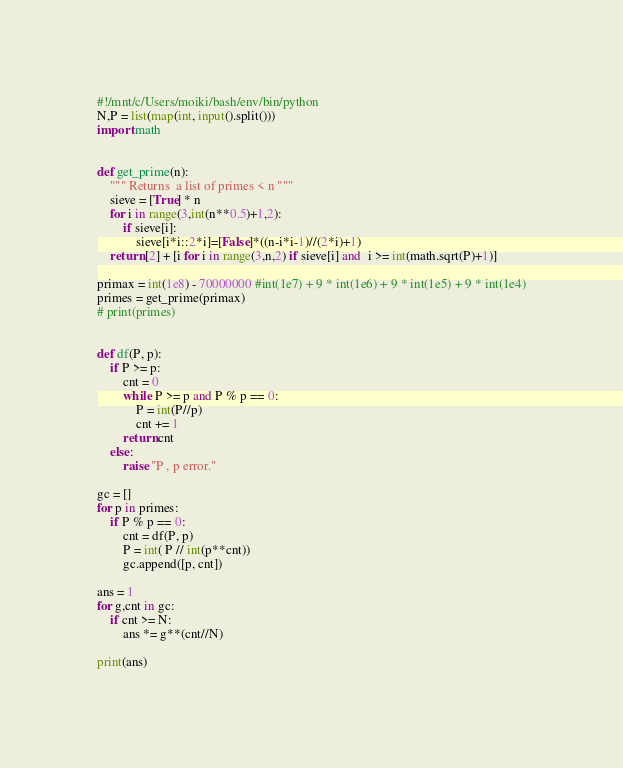Convert code to text. <code><loc_0><loc_0><loc_500><loc_500><_Python_>#!/mnt/c/Users/moiki/bash/env/bin/python
N,P = list(map(int, input().split()))
import math


def get_prime(n):
    """ Returns  a list of primes < n """
    sieve = [True] * n
    for i in range(3,int(n**0.5)+1,2):
        if sieve[i]:
            sieve[i*i::2*i]=[False]*((n-i*i-1)//(2*i)+1)
    return [2] + [i for i in range(3,n,2) if sieve[i] and  i >= int(math.sqrt(P)+1)]

primax = int(1e8) - 70000000 #int(1e7) + 9 * int(1e6) + 9 * int(1e5) + 9 * int(1e4)
primes = get_prime(primax)
# print(primes)


def df(P, p):
    if P >= p:
        cnt = 0
        while P >= p and P % p == 0:
            P = int(P//p)
            cnt += 1
        return cnt
    else:
        raise "P , p error."

gc = []
for p in primes:
    if P % p == 0:
        cnt = df(P, p)
        P = int( P // int(p**cnt))
        gc.append([p, cnt])

ans = 1
for g,cnt in gc:
    if cnt >= N:
        ans *= g**(cnt//N)

print(ans)
</code> 